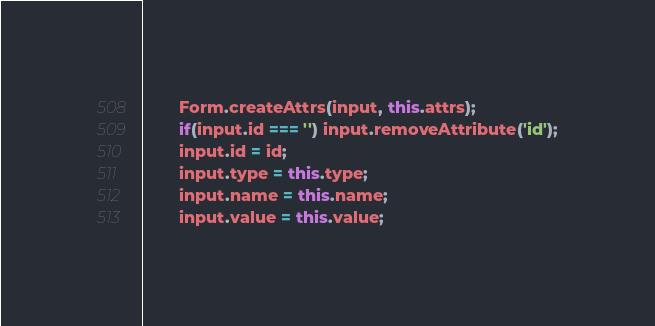<code> <loc_0><loc_0><loc_500><loc_500><_JavaScript_>        Form.createAttrs(input, this.attrs);
        if(input.id === '') input.removeAttribute('id');
        input.id = id;
        input.type = this.type;
        input.name = this.name;
        input.value = this.value;
</code> 